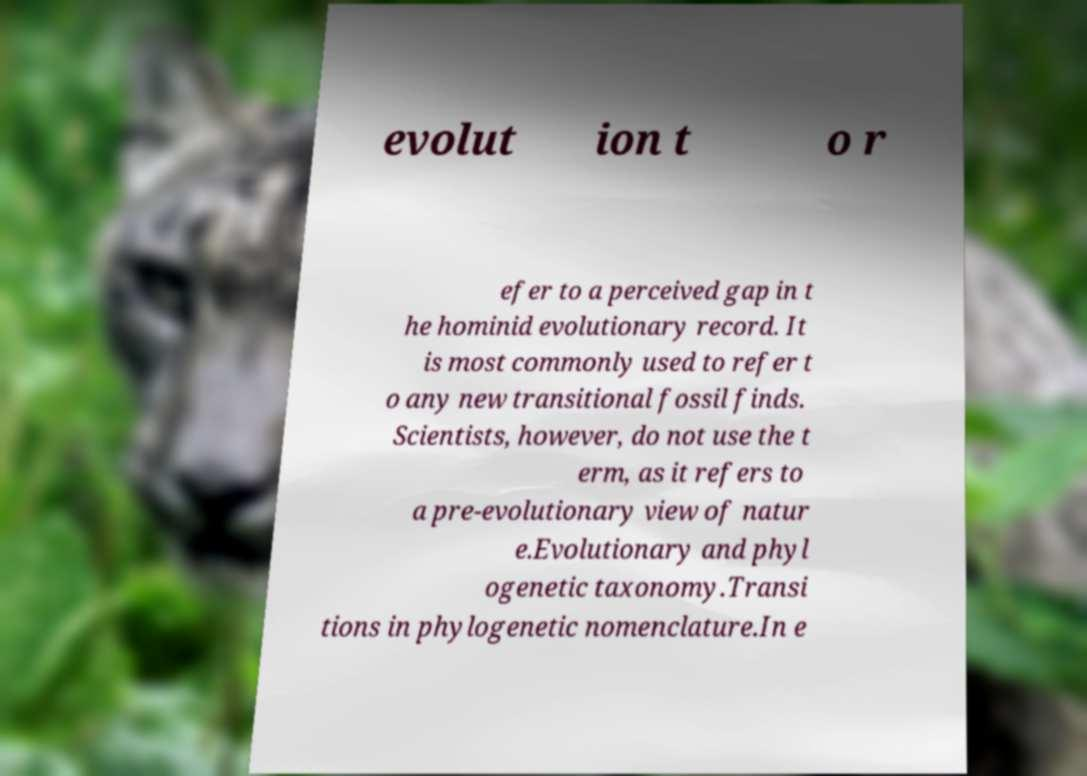What messages or text are displayed in this image? I need them in a readable, typed format. evolut ion t o r efer to a perceived gap in t he hominid evolutionary record. It is most commonly used to refer t o any new transitional fossil finds. Scientists, however, do not use the t erm, as it refers to a pre-evolutionary view of natur e.Evolutionary and phyl ogenetic taxonomy.Transi tions in phylogenetic nomenclature.In e 